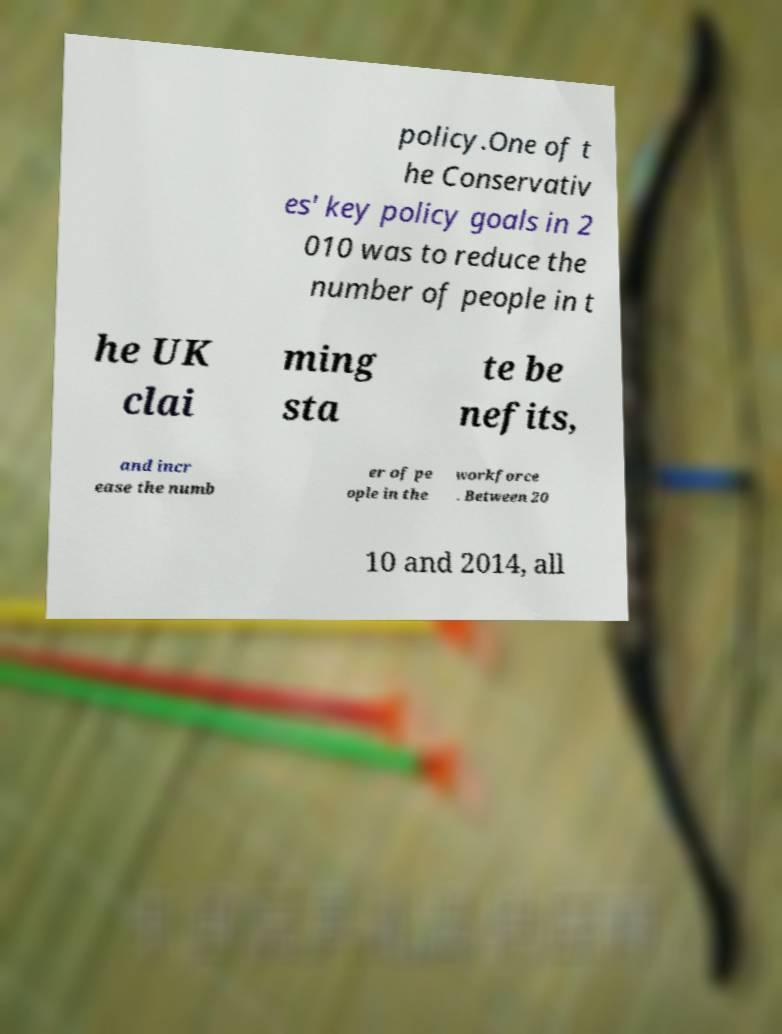Can you read and provide the text displayed in the image?This photo seems to have some interesting text. Can you extract and type it out for me? policy.One of t he Conservativ es' key policy goals in 2 010 was to reduce the number of people in t he UK clai ming sta te be nefits, and incr ease the numb er of pe ople in the workforce . Between 20 10 and 2014, all 